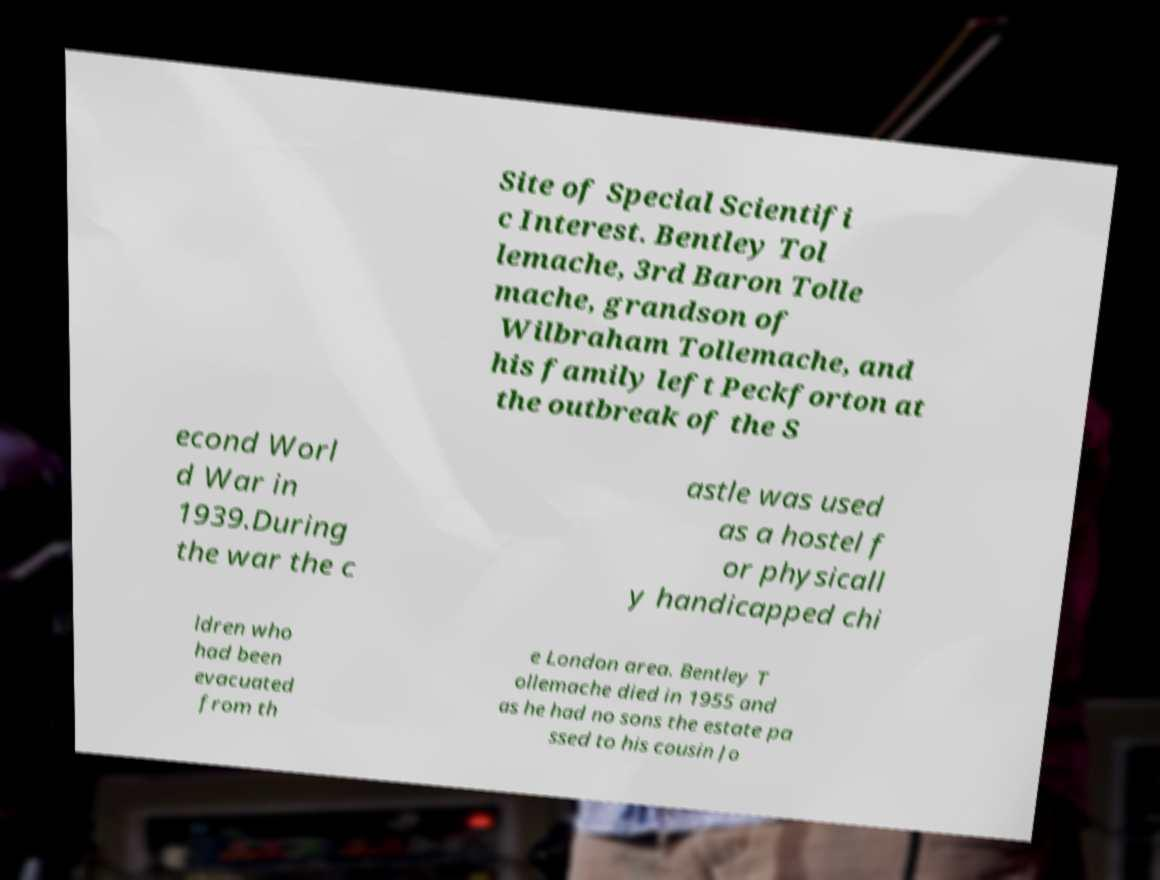Can you read and provide the text displayed in the image?This photo seems to have some interesting text. Can you extract and type it out for me? Site of Special Scientifi c Interest. Bentley Tol lemache, 3rd Baron Tolle mache, grandson of Wilbraham Tollemache, and his family left Peckforton at the outbreak of the S econd Worl d War in 1939.During the war the c astle was used as a hostel f or physicall y handicapped chi ldren who had been evacuated from th e London area. Bentley T ollemache died in 1955 and as he had no sons the estate pa ssed to his cousin Jo 